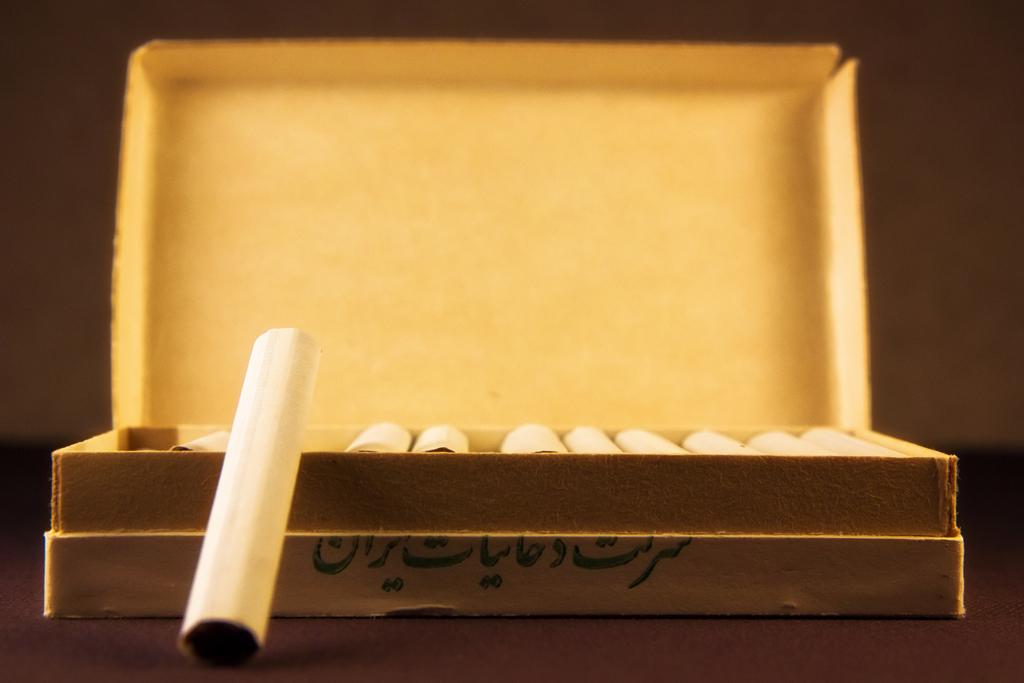What object is the main subject of the image? There is a box in the image. What is inside the box can be seen? There are rolled papers in the box. Can you describe the background of the image? The background of the image is blurry. What type of country can be seen in the background of the image? There is no country visible in the image, as the background is blurry and does not show any recognizable geographical features. 